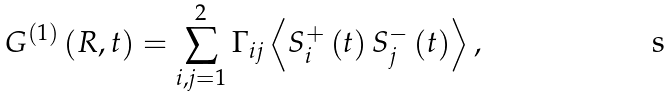<formula> <loc_0><loc_0><loc_500><loc_500>G ^ { \left ( 1 \right ) } \left ( { R } , t \right ) = \sum _ { i , j = 1 } ^ { 2 } \Gamma _ { i j } \left \langle S _ { i } ^ { + } \left ( t \right ) S _ { j } ^ { - } \left ( t \right ) \right \rangle ,</formula> 